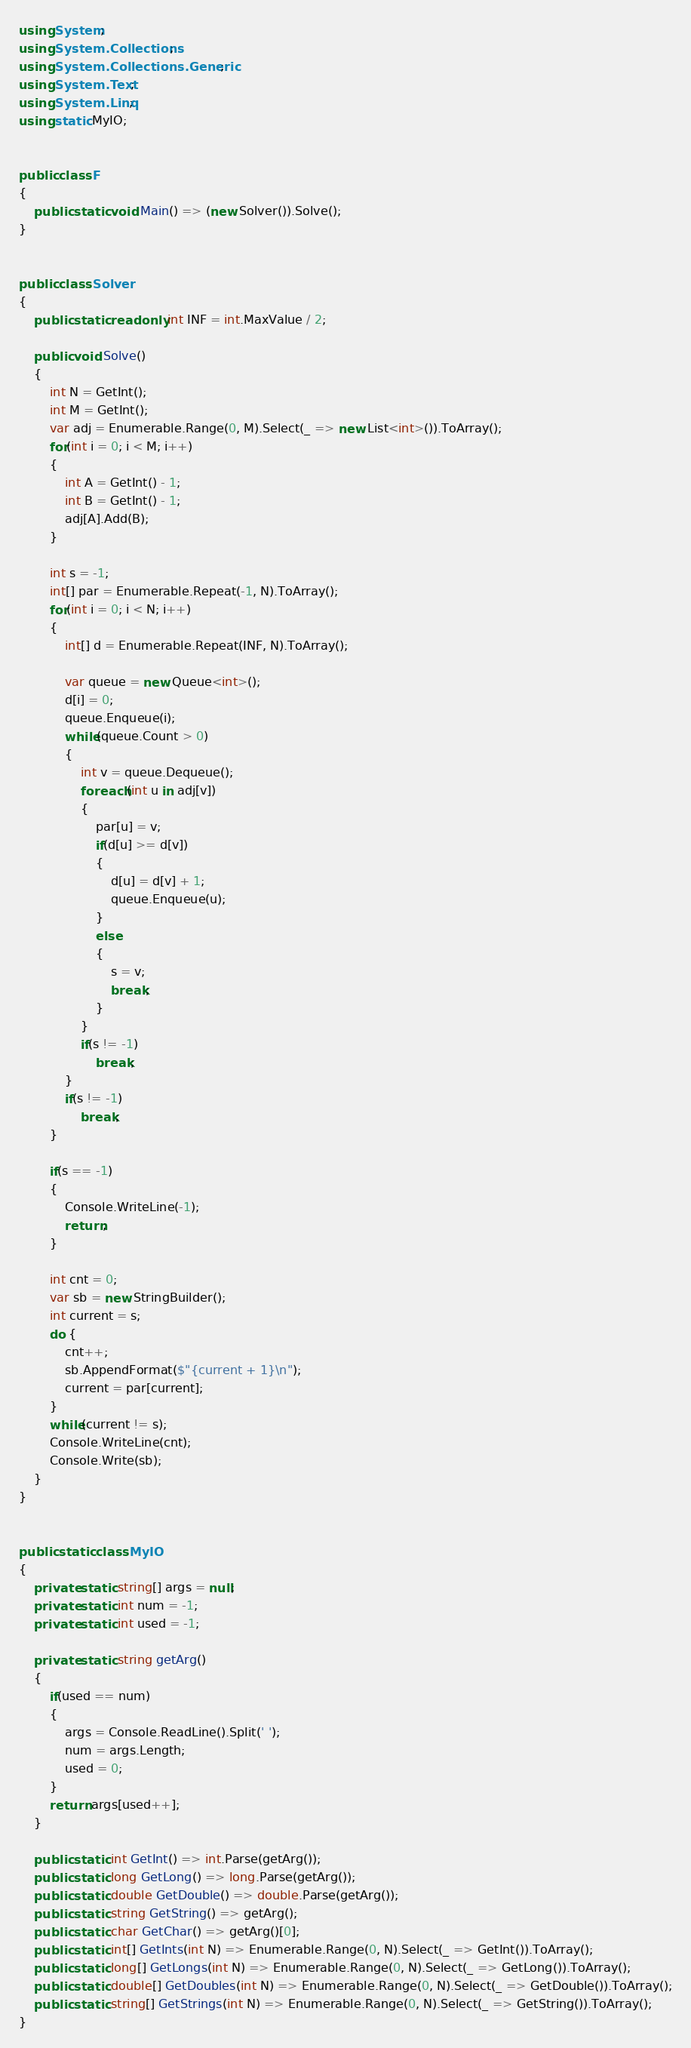<code> <loc_0><loc_0><loc_500><loc_500><_C#_>using System;
using System.Collections;
using System.Collections.Generic;
using System.Text;
using System.Linq;
using static MyIO;


public class F
{
	public static void Main() => (new Solver()).Solve();
}


public class Solver
{
	public static readonly int INF = int.MaxValue / 2;

	public void Solve()
	{
		int N = GetInt();
		int M = GetInt();
		var adj = Enumerable.Range(0, M).Select(_ => new List<int>()).ToArray();
		for(int i = 0; i < M; i++)
		{
			int A = GetInt() - 1;
			int B = GetInt() - 1;
			adj[A].Add(B);
		}

		int s = -1;
		int[] par = Enumerable.Repeat(-1, N).ToArray();
		for(int i = 0; i < N; i++)
		{			
			int[] d = Enumerable.Repeat(INF, N).ToArray();

			var queue = new Queue<int>();
			d[i] = 0;
			queue.Enqueue(i);
			while(queue.Count > 0)
			{
				int v = queue.Dequeue();
				foreach(int u in adj[v])
				{
					par[u] = v;
					if(d[u] >= d[v])
					{
						d[u] = d[v] + 1;
						queue.Enqueue(u);
					}
					else
					{
						s = v;
						break;
					}
				}
				if(s != -1)
					break;
			}
			if(s != -1)
				break;
		}

		if(s == -1)
		{
			Console.WriteLine(-1);
			return;
		}

		int cnt = 0;
		var sb = new StringBuilder();
		int current = s;
		do {
			cnt++;
			sb.AppendFormat($"{current + 1}\n");
			current = par[current];
		}
		while(current != s);
		Console.WriteLine(cnt);
		Console.Write(sb);
	}
}


public static class MyIO
{
	private static string[] args = null;
	private static int num = -1;
	private static int used = -1;

	private static string getArg()
	{
		if(used == num)
		{
			args = Console.ReadLine().Split(' ');
			num = args.Length;
			used = 0;
		}
		return args[used++];
	}

	public static int GetInt() => int.Parse(getArg());
	public static long GetLong() => long.Parse(getArg());
	public static double GetDouble() => double.Parse(getArg());
	public static string GetString() => getArg();
	public static char GetChar() => getArg()[0];
	public static int[] GetInts(int N) => Enumerable.Range(0, N).Select(_ => GetInt()).ToArray();
	public static long[] GetLongs(int N) => Enumerable.Range(0, N).Select(_ => GetLong()).ToArray();
	public static double[] GetDoubles(int N) => Enumerable.Range(0, N).Select(_ => GetDouble()).ToArray();
	public static string[] GetStrings(int N) => Enumerable.Range(0, N).Select(_ => GetString()).ToArray();
}
</code> 